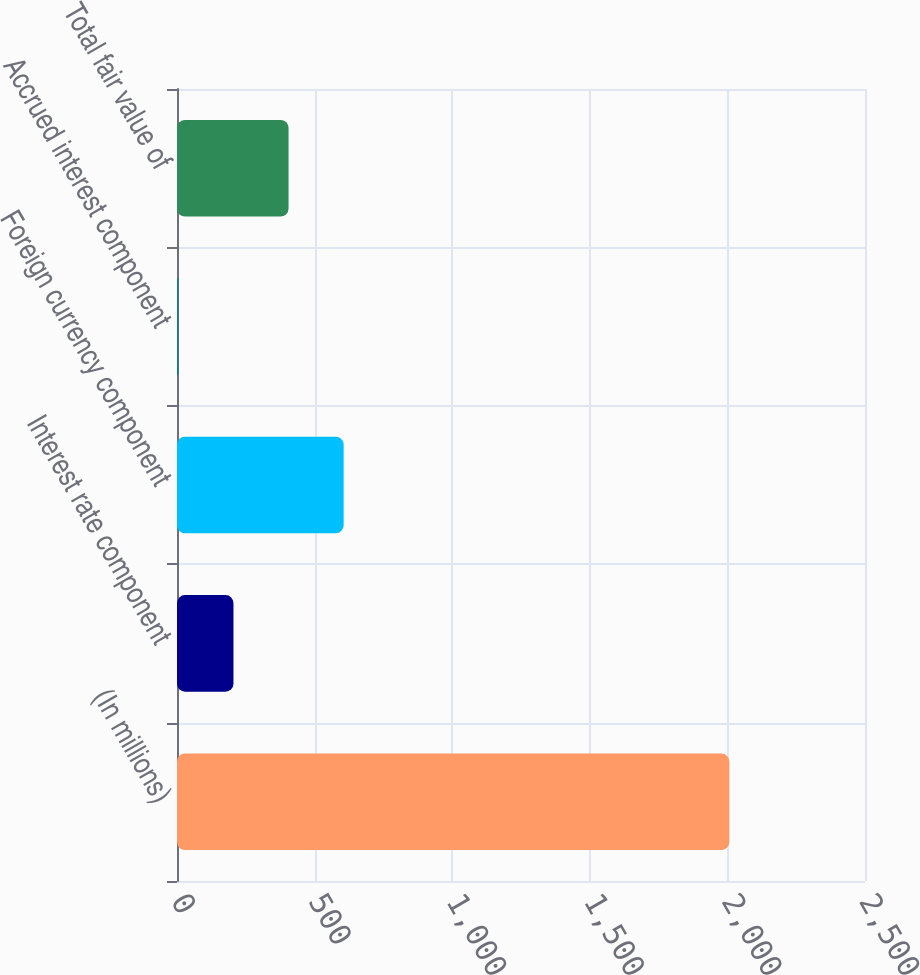Convert chart to OTSL. <chart><loc_0><loc_0><loc_500><loc_500><bar_chart><fcel>(In millions)<fcel>Interest rate component<fcel>Foreign currency component<fcel>Accrued interest component<fcel>Total fair value of<nl><fcel>2007<fcel>205.2<fcel>605.6<fcel>5<fcel>405.4<nl></chart> 